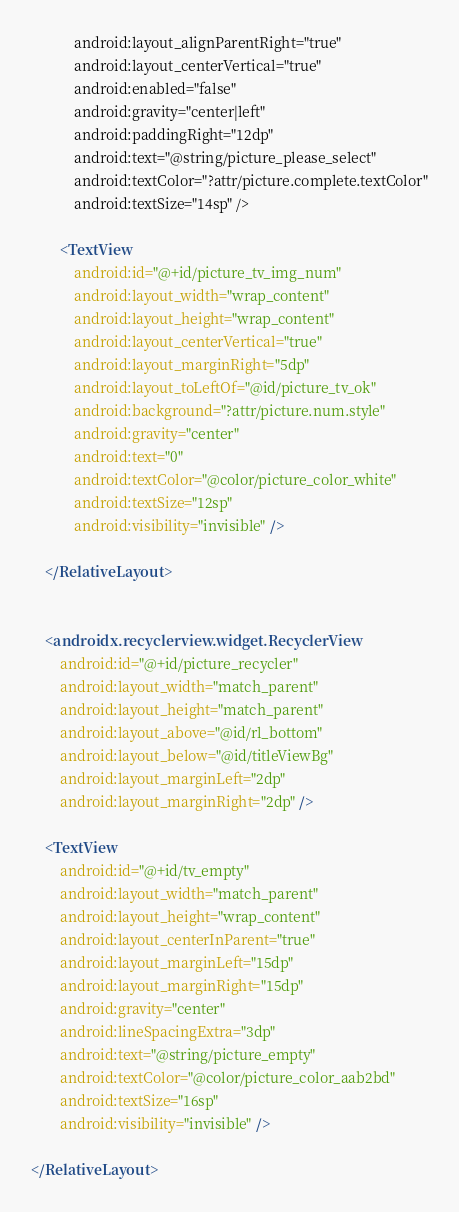Convert code to text. <code><loc_0><loc_0><loc_500><loc_500><_XML_>            android:layout_alignParentRight="true"
            android:layout_centerVertical="true"
            android:enabled="false"
            android:gravity="center|left"
            android:paddingRight="12dp"
            android:text="@string/picture_please_select"
            android:textColor="?attr/picture.complete.textColor"
            android:textSize="14sp" />

        <TextView
            android:id="@+id/picture_tv_img_num"
            android:layout_width="wrap_content"
            android:layout_height="wrap_content"
            android:layout_centerVertical="true"
            android:layout_marginRight="5dp"
            android:layout_toLeftOf="@id/picture_tv_ok"
            android:background="?attr/picture.num.style"
            android:gravity="center"
            android:text="0"
            android:textColor="@color/picture_color_white"
            android:textSize="12sp"
            android:visibility="invisible" />

    </RelativeLayout>


    <androidx.recyclerview.widget.RecyclerView
        android:id="@+id/picture_recycler"
        android:layout_width="match_parent"
        android:layout_height="match_parent"
        android:layout_above="@id/rl_bottom"
        android:layout_below="@id/titleViewBg"
        android:layout_marginLeft="2dp"
        android:layout_marginRight="2dp" />

    <TextView
        android:id="@+id/tv_empty"
        android:layout_width="match_parent"
        android:layout_height="wrap_content"
        android:layout_centerInParent="true"
        android:layout_marginLeft="15dp"
        android:layout_marginRight="15dp"
        android:gravity="center"
        android:lineSpacingExtra="3dp"
        android:text="@string/picture_empty"
        android:textColor="@color/picture_color_aab2bd"
        android:textSize="16sp"
        android:visibility="invisible" />

</RelativeLayout>
</code> 